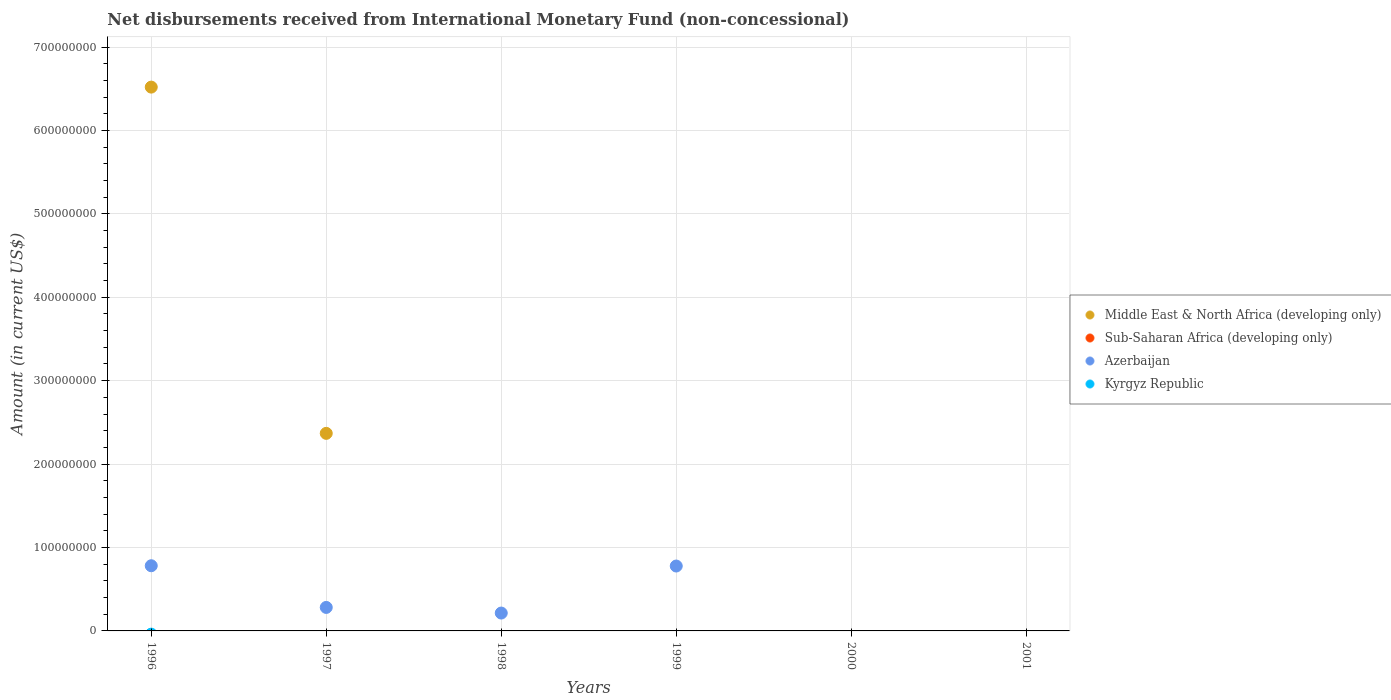How many different coloured dotlines are there?
Your answer should be very brief. 2. Is the number of dotlines equal to the number of legend labels?
Ensure brevity in your answer.  No. What is the amount of disbursements received from International Monetary Fund in Azerbaijan in 1999?
Give a very brief answer. 7.78e+07. Across all years, what is the maximum amount of disbursements received from International Monetary Fund in Azerbaijan?
Provide a succinct answer. 7.81e+07. Across all years, what is the minimum amount of disbursements received from International Monetary Fund in Kyrgyz Republic?
Give a very brief answer. 0. In which year was the amount of disbursements received from International Monetary Fund in Middle East & North Africa (developing only) maximum?
Offer a terse response. 1996. What is the total amount of disbursements received from International Monetary Fund in Sub-Saharan Africa (developing only) in the graph?
Provide a succinct answer. 0. What is the difference between the amount of disbursements received from International Monetary Fund in Middle East & North Africa (developing only) in 1996 and that in 1997?
Your response must be concise. 4.15e+08. What is the difference between the amount of disbursements received from International Monetary Fund in Kyrgyz Republic in 1998 and the amount of disbursements received from International Monetary Fund in Middle East & North Africa (developing only) in 1999?
Provide a succinct answer. 0. What is the average amount of disbursements received from International Monetary Fund in Sub-Saharan Africa (developing only) per year?
Offer a terse response. 0. In the year 1997, what is the difference between the amount of disbursements received from International Monetary Fund in Azerbaijan and amount of disbursements received from International Monetary Fund in Middle East & North Africa (developing only)?
Ensure brevity in your answer.  -2.09e+08. In how many years, is the amount of disbursements received from International Monetary Fund in Middle East & North Africa (developing only) greater than 620000000 US$?
Ensure brevity in your answer.  1. What is the difference between the highest and the second highest amount of disbursements received from International Monetary Fund in Azerbaijan?
Keep it short and to the point. 3.42e+05. What is the difference between the highest and the lowest amount of disbursements received from International Monetary Fund in Middle East & North Africa (developing only)?
Your answer should be compact. 6.52e+08. Is it the case that in every year, the sum of the amount of disbursements received from International Monetary Fund in Azerbaijan and amount of disbursements received from International Monetary Fund in Middle East & North Africa (developing only)  is greater than the sum of amount of disbursements received from International Monetary Fund in Kyrgyz Republic and amount of disbursements received from International Monetary Fund in Sub-Saharan Africa (developing only)?
Make the answer very short. No. Is it the case that in every year, the sum of the amount of disbursements received from International Monetary Fund in Azerbaijan and amount of disbursements received from International Monetary Fund in Middle East & North Africa (developing only)  is greater than the amount of disbursements received from International Monetary Fund in Sub-Saharan Africa (developing only)?
Provide a succinct answer. No. Does the amount of disbursements received from International Monetary Fund in Sub-Saharan Africa (developing only) monotonically increase over the years?
Offer a terse response. No. Is the amount of disbursements received from International Monetary Fund in Middle East & North Africa (developing only) strictly less than the amount of disbursements received from International Monetary Fund in Azerbaijan over the years?
Ensure brevity in your answer.  No. How many dotlines are there?
Make the answer very short. 2. What is the difference between two consecutive major ticks on the Y-axis?
Your response must be concise. 1.00e+08. Does the graph contain any zero values?
Offer a very short reply. Yes. Does the graph contain grids?
Provide a succinct answer. Yes. What is the title of the graph?
Provide a short and direct response. Net disbursements received from International Monetary Fund (non-concessional). What is the Amount (in current US$) of Middle East & North Africa (developing only) in 1996?
Provide a succinct answer. 6.52e+08. What is the Amount (in current US$) of Azerbaijan in 1996?
Offer a very short reply. 7.81e+07. What is the Amount (in current US$) of Middle East & North Africa (developing only) in 1997?
Offer a very short reply. 2.37e+08. What is the Amount (in current US$) in Azerbaijan in 1997?
Ensure brevity in your answer.  2.82e+07. What is the Amount (in current US$) in Kyrgyz Republic in 1997?
Make the answer very short. 0. What is the Amount (in current US$) in Sub-Saharan Africa (developing only) in 1998?
Offer a very short reply. 0. What is the Amount (in current US$) of Azerbaijan in 1998?
Offer a terse response. 2.14e+07. What is the Amount (in current US$) of Kyrgyz Republic in 1998?
Keep it short and to the point. 0. What is the Amount (in current US$) in Middle East & North Africa (developing only) in 1999?
Offer a very short reply. 0. What is the Amount (in current US$) of Azerbaijan in 1999?
Your answer should be compact. 7.78e+07. What is the Amount (in current US$) in Middle East & North Africa (developing only) in 2000?
Offer a very short reply. 0. What is the Amount (in current US$) of Sub-Saharan Africa (developing only) in 2000?
Offer a very short reply. 0. What is the Amount (in current US$) in Azerbaijan in 2000?
Make the answer very short. 0. What is the Amount (in current US$) in Kyrgyz Republic in 2000?
Your answer should be compact. 0. What is the Amount (in current US$) of Sub-Saharan Africa (developing only) in 2001?
Give a very brief answer. 0. What is the Amount (in current US$) of Azerbaijan in 2001?
Make the answer very short. 0. Across all years, what is the maximum Amount (in current US$) in Middle East & North Africa (developing only)?
Make the answer very short. 6.52e+08. Across all years, what is the maximum Amount (in current US$) in Azerbaijan?
Your response must be concise. 7.81e+07. Across all years, what is the minimum Amount (in current US$) in Azerbaijan?
Ensure brevity in your answer.  0. What is the total Amount (in current US$) of Middle East & North Africa (developing only) in the graph?
Ensure brevity in your answer.  8.89e+08. What is the total Amount (in current US$) in Sub-Saharan Africa (developing only) in the graph?
Give a very brief answer. 0. What is the total Amount (in current US$) in Azerbaijan in the graph?
Make the answer very short. 2.06e+08. What is the difference between the Amount (in current US$) of Middle East & North Africa (developing only) in 1996 and that in 1997?
Offer a very short reply. 4.15e+08. What is the difference between the Amount (in current US$) in Azerbaijan in 1996 and that in 1997?
Keep it short and to the point. 5.00e+07. What is the difference between the Amount (in current US$) of Azerbaijan in 1996 and that in 1998?
Keep it short and to the point. 5.67e+07. What is the difference between the Amount (in current US$) in Azerbaijan in 1996 and that in 1999?
Offer a very short reply. 3.42e+05. What is the difference between the Amount (in current US$) in Azerbaijan in 1997 and that in 1998?
Offer a terse response. 6.74e+06. What is the difference between the Amount (in current US$) of Azerbaijan in 1997 and that in 1999?
Offer a very short reply. -4.96e+07. What is the difference between the Amount (in current US$) in Azerbaijan in 1998 and that in 1999?
Provide a succinct answer. -5.64e+07. What is the difference between the Amount (in current US$) in Middle East & North Africa (developing only) in 1996 and the Amount (in current US$) in Azerbaijan in 1997?
Your answer should be very brief. 6.24e+08. What is the difference between the Amount (in current US$) of Middle East & North Africa (developing only) in 1996 and the Amount (in current US$) of Azerbaijan in 1998?
Provide a short and direct response. 6.30e+08. What is the difference between the Amount (in current US$) in Middle East & North Africa (developing only) in 1996 and the Amount (in current US$) in Azerbaijan in 1999?
Keep it short and to the point. 5.74e+08. What is the difference between the Amount (in current US$) of Middle East & North Africa (developing only) in 1997 and the Amount (in current US$) of Azerbaijan in 1998?
Keep it short and to the point. 2.15e+08. What is the difference between the Amount (in current US$) in Middle East & North Africa (developing only) in 1997 and the Amount (in current US$) in Azerbaijan in 1999?
Provide a succinct answer. 1.59e+08. What is the average Amount (in current US$) of Middle East & North Africa (developing only) per year?
Your response must be concise. 1.48e+08. What is the average Amount (in current US$) of Azerbaijan per year?
Your answer should be compact. 3.43e+07. What is the average Amount (in current US$) of Kyrgyz Republic per year?
Ensure brevity in your answer.  0. In the year 1996, what is the difference between the Amount (in current US$) of Middle East & North Africa (developing only) and Amount (in current US$) of Azerbaijan?
Offer a very short reply. 5.74e+08. In the year 1997, what is the difference between the Amount (in current US$) of Middle East & North Africa (developing only) and Amount (in current US$) of Azerbaijan?
Offer a very short reply. 2.09e+08. What is the ratio of the Amount (in current US$) in Middle East & North Africa (developing only) in 1996 to that in 1997?
Make the answer very short. 2.75. What is the ratio of the Amount (in current US$) in Azerbaijan in 1996 to that in 1997?
Your answer should be very brief. 2.77. What is the ratio of the Amount (in current US$) of Azerbaijan in 1996 to that in 1998?
Provide a short and direct response. 3.65. What is the ratio of the Amount (in current US$) of Azerbaijan in 1996 to that in 1999?
Give a very brief answer. 1. What is the ratio of the Amount (in current US$) in Azerbaijan in 1997 to that in 1998?
Your answer should be compact. 1.31. What is the ratio of the Amount (in current US$) of Azerbaijan in 1997 to that in 1999?
Ensure brevity in your answer.  0.36. What is the ratio of the Amount (in current US$) in Azerbaijan in 1998 to that in 1999?
Keep it short and to the point. 0.28. What is the difference between the highest and the second highest Amount (in current US$) in Azerbaijan?
Your response must be concise. 3.42e+05. What is the difference between the highest and the lowest Amount (in current US$) of Middle East & North Africa (developing only)?
Your answer should be compact. 6.52e+08. What is the difference between the highest and the lowest Amount (in current US$) of Azerbaijan?
Keep it short and to the point. 7.81e+07. 